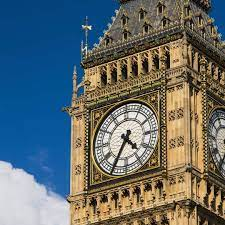Can you tell me more about the history of Big Ben? Certainly! Big Ben was completed in 1859 and is actually the nickname for the Great Bell of the clock at the north end of the Palace of Westminster. The name is often extended to also refer to both the clock and the clock tower. It was designed by architect Augustus Pugin, and the tower holds a four-faced clock that has been working since its completion, despite having faced multiple renovations. What events did Big Ben witness? Over the years, Big Ben has been a silent witness to many key events in British history, including World War II, during which it continued to chime even during the Blitz. It's also a focal point during New Year's Eve celebrations and has been a rallying point for various political and social movements. 